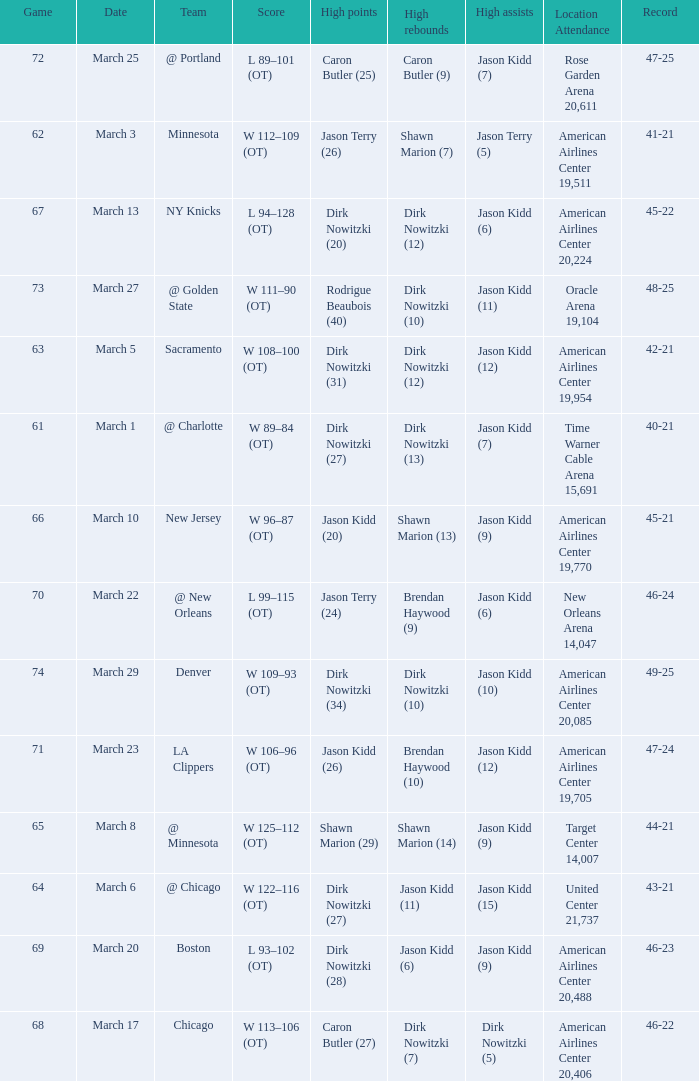List the stadium and number of people in attendance when the team record was 45-22. 1.0. 